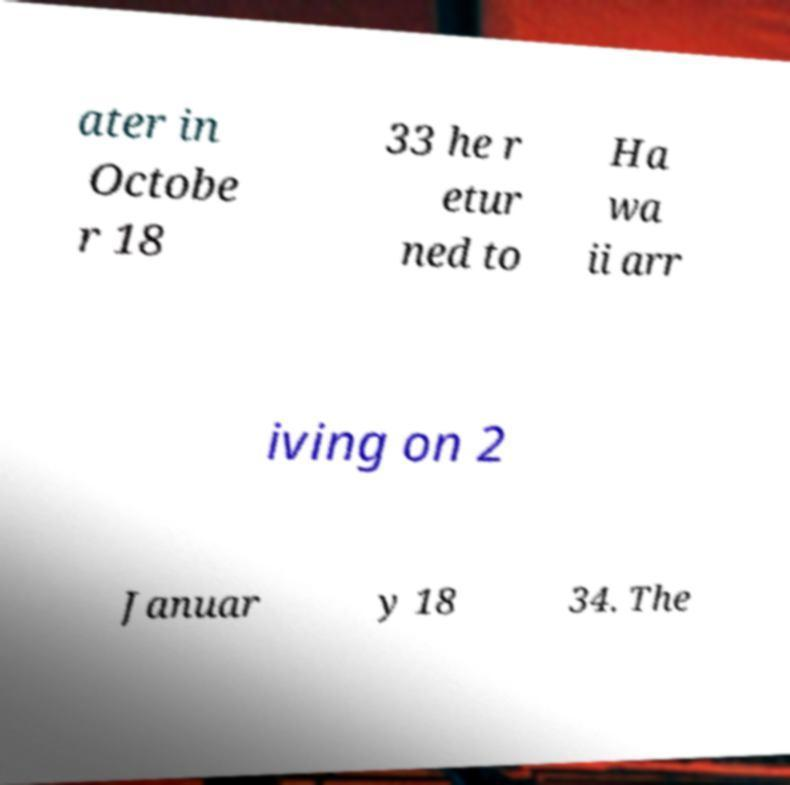Please read and relay the text visible in this image. What does it say? ater in Octobe r 18 33 he r etur ned to Ha wa ii arr iving on 2 Januar y 18 34. The 